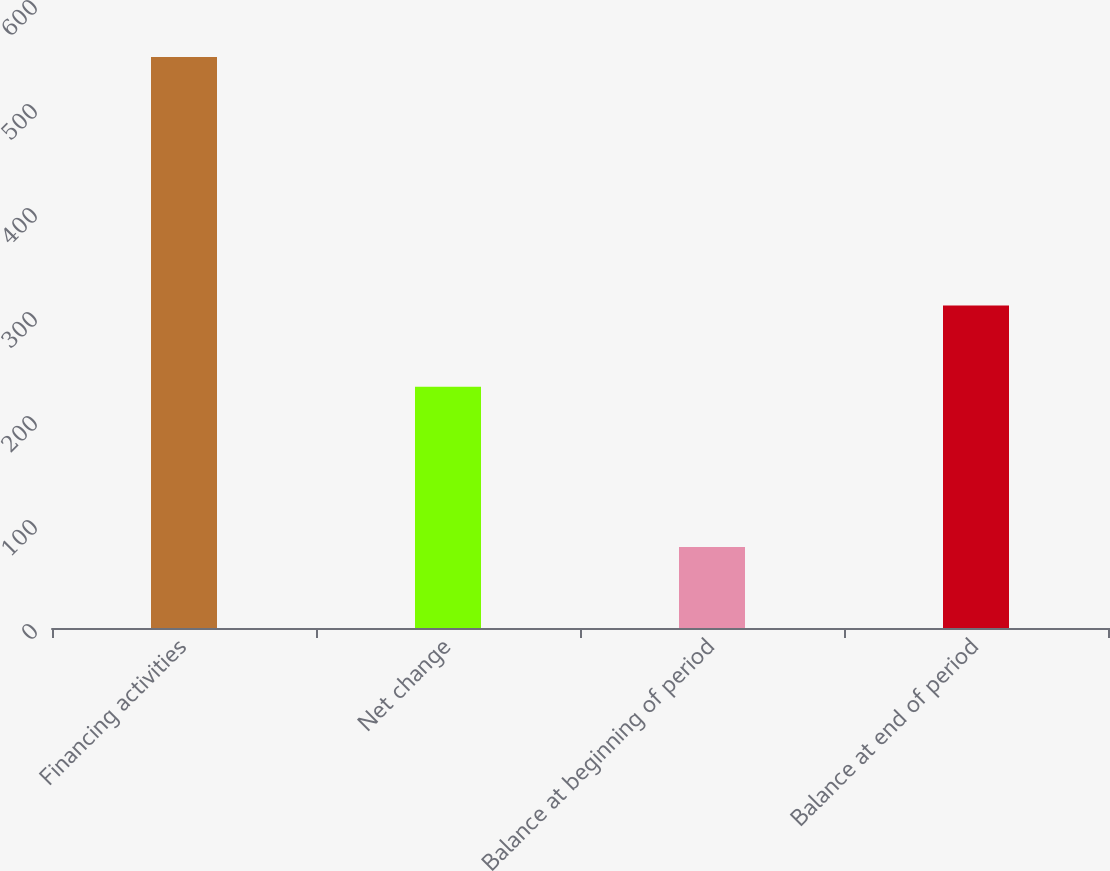Convert chart. <chart><loc_0><loc_0><loc_500><loc_500><bar_chart><fcel>Financing activities<fcel>Net change<fcel>Balance at beginning of period<fcel>Balance at end of period<nl><fcel>549<fcel>232<fcel>78<fcel>310<nl></chart> 